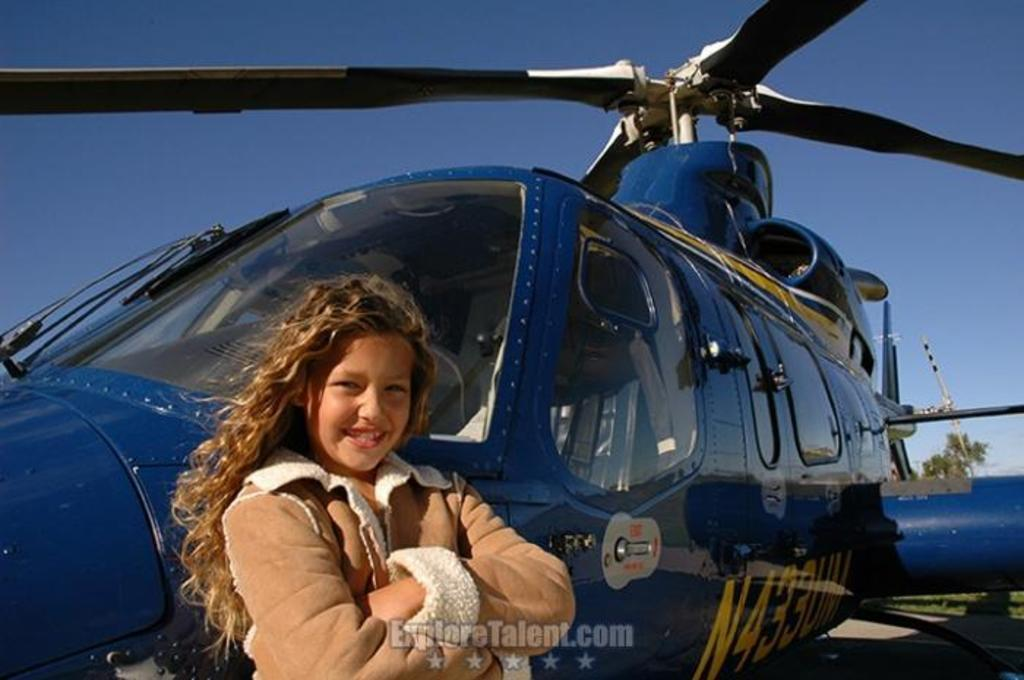<image>
Offer a succinct explanation of the picture presented. a girl with an exploretalent site under her 